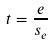<formula> <loc_0><loc_0><loc_500><loc_500>t = \frac { e } { s _ { e } }</formula> 